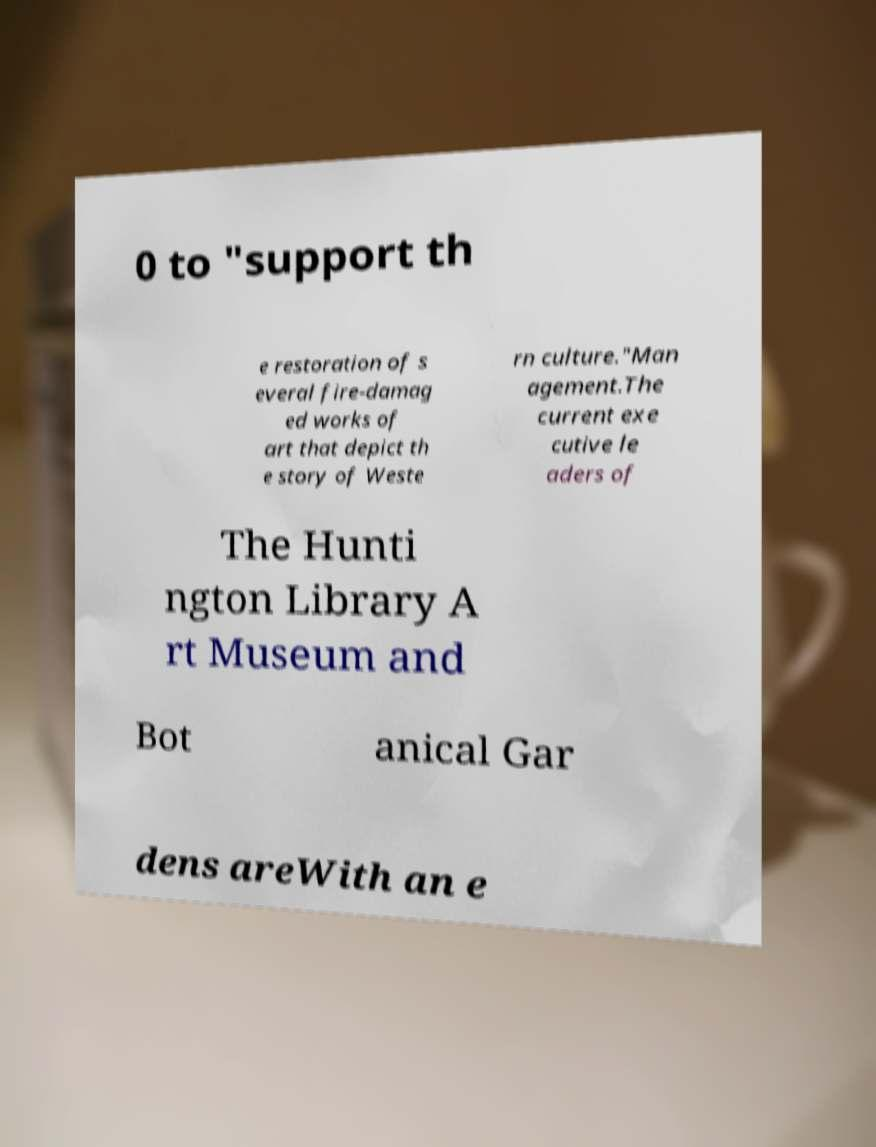There's text embedded in this image that I need extracted. Can you transcribe it verbatim? 0 to "support th e restoration of s everal fire-damag ed works of art that depict th e story of Weste rn culture."Man agement.The current exe cutive le aders of The Hunti ngton Library A rt Museum and Bot anical Gar dens areWith an e 